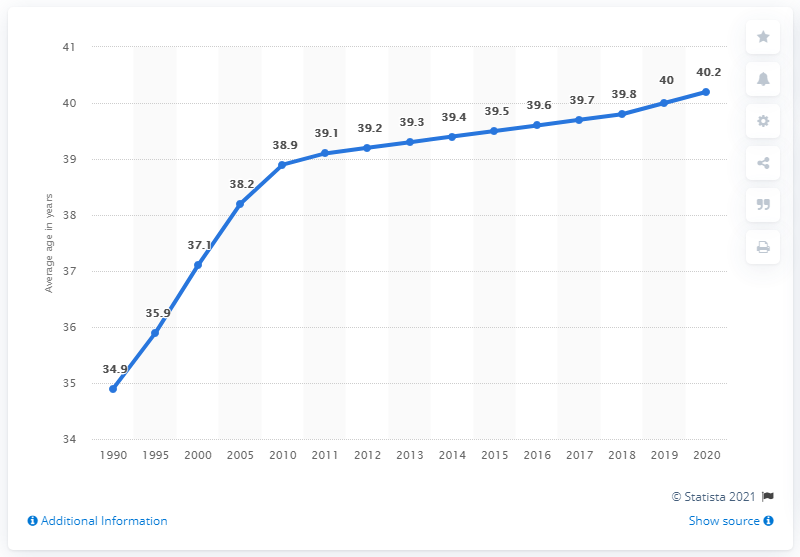How might the demographic changes illustrated in this graph impact Russia's economic policies? The aging population trend shown in the graph could pressurize Russia to adjust its economic policies, particularly in areas like pensions, healthcare, and workforce development. An older average age could mean more resources directed towards healthcare and retirement benefits, as well as initiatives to boost workforce participation among the youth and older citizens alike. 